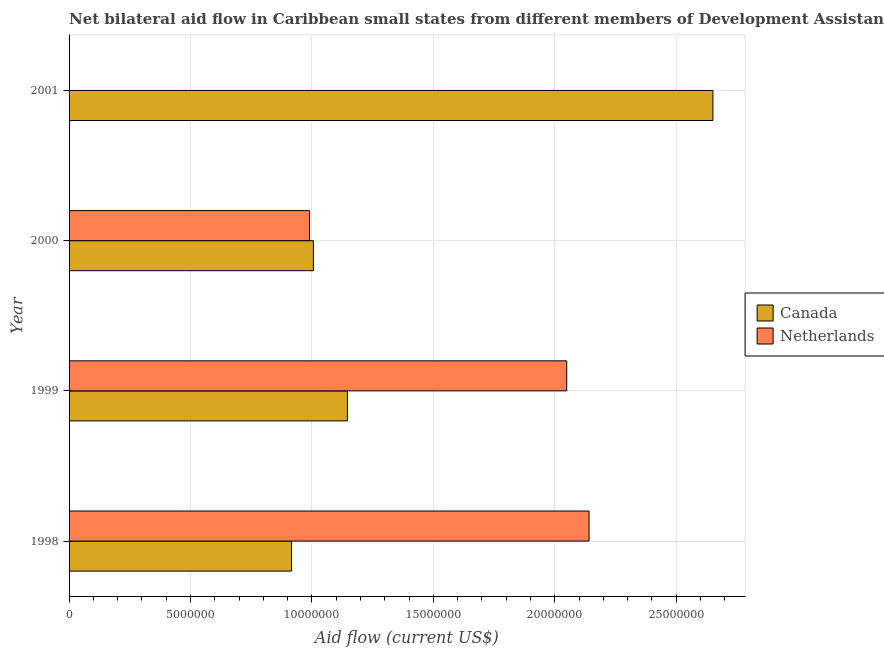How many different coloured bars are there?
Provide a short and direct response. 2. How many bars are there on the 3rd tick from the top?
Offer a very short reply. 2. How many bars are there on the 2nd tick from the bottom?
Ensure brevity in your answer.  2. What is the label of the 1st group of bars from the top?
Your answer should be compact. 2001. In how many cases, is the number of bars for a given year not equal to the number of legend labels?
Provide a short and direct response. 1. What is the amount of aid given by canada in 1998?
Make the answer very short. 9.16e+06. Across all years, what is the maximum amount of aid given by netherlands?
Your answer should be very brief. 2.14e+07. Across all years, what is the minimum amount of aid given by canada?
Provide a short and direct response. 9.16e+06. In which year was the amount of aid given by canada maximum?
Offer a terse response. 2001. What is the total amount of aid given by canada in the graph?
Give a very brief answer. 5.72e+07. What is the difference between the amount of aid given by canada in 1998 and that in 2001?
Give a very brief answer. -1.74e+07. What is the difference between the amount of aid given by canada in 1999 and the amount of aid given by netherlands in 1998?
Make the answer very short. -9.95e+06. What is the average amount of aid given by canada per year?
Provide a succinct answer. 1.43e+07. In the year 1998, what is the difference between the amount of aid given by canada and amount of aid given by netherlands?
Make the answer very short. -1.22e+07. What is the ratio of the amount of aid given by canada in 1999 to that in 2000?
Offer a very short reply. 1.14. Is the amount of aid given by canada in 1999 less than that in 2000?
Provide a succinct answer. No. Is the difference between the amount of aid given by netherlands in 1998 and 1999 greater than the difference between the amount of aid given by canada in 1998 and 1999?
Your answer should be compact. Yes. What is the difference between the highest and the second highest amount of aid given by netherlands?
Your answer should be compact. 9.20e+05. What is the difference between the highest and the lowest amount of aid given by canada?
Keep it short and to the point. 1.74e+07. In how many years, is the amount of aid given by canada greater than the average amount of aid given by canada taken over all years?
Make the answer very short. 1. How many years are there in the graph?
Your response must be concise. 4. Does the graph contain grids?
Your answer should be compact. Yes. Where does the legend appear in the graph?
Keep it short and to the point. Center right. How many legend labels are there?
Make the answer very short. 2. How are the legend labels stacked?
Offer a terse response. Vertical. What is the title of the graph?
Make the answer very short. Net bilateral aid flow in Caribbean small states from different members of Development Assistance Committee. What is the label or title of the Y-axis?
Your answer should be very brief. Year. What is the Aid flow (current US$) of Canada in 1998?
Your response must be concise. 9.16e+06. What is the Aid flow (current US$) in Netherlands in 1998?
Offer a very short reply. 2.14e+07. What is the Aid flow (current US$) of Canada in 1999?
Make the answer very short. 1.15e+07. What is the Aid flow (current US$) of Netherlands in 1999?
Your response must be concise. 2.05e+07. What is the Aid flow (current US$) of Canada in 2000?
Ensure brevity in your answer.  1.01e+07. What is the Aid flow (current US$) of Netherlands in 2000?
Make the answer very short. 9.90e+06. What is the Aid flow (current US$) in Canada in 2001?
Your answer should be compact. 2.65e+07. Across all years, what is the maximum Aid flow (current US$) in Canada?
Offer a terse response. 2.65e+07. Across all years, what is the maximum Aid flow (current US$) of Netherlands?
Give a very brief answer. 2.14e+07. Across all years, what is the minimum Aid flow (current US$) in Canada?
Ensure brevity in your answer.  9.16e+06. What is the total Aid flow (current US$) of Canada in the graph?
Offer a terse response. 5.72e+07. What is the total Aid flow (current US$) in Netherlands in the graph?
Give a very brief answer. 5.18e+07. What is the difference between the Aid flow (current US$) in Canada in 1998 and that in 1999?
Ensure brevity in your answer.  -2.30e+06. What is the difference between the Aid flow (current US$) in Netherlands in 1998 and that in 1999?
Give a very brief answer. 9.20e+05. What is the difference between the Aid flow (current US$) in Canada in 1998 and that in 2000?
Ensure brevity in your answer.  -9.00e+05. What is the difference between the Aid flow (current US$) of Netherlands in 1998 and that in 2000?
Your answer should be very brief. 1.15e+07. What is the difference between the Aid flow (current US$) in Canada in 1998 and that in 2001?
Your answer should be very brief. -1.74e+07. What is the difference between the Aid flow (current US$) of Canada in 1999 and that in 2000?
Offer a terse response. 1.40e+06. What is the difference between the Aid flow (current US$) of Netherlands in 1999 and that in 2000?
Provide a short and direct response. 1.06e+07. What is the difference between the Aid flow (current US$) in Canada in 1999 and that in 2001?
Provide a short and direct response. -1.50e+07. What is the difference between the Aid flow (current US$) of Canada in 2000 and that in 2001?
Your response must be concise. -1.64e+07. What is the difference between the Aid flow (current US$) of Canada in 1998 and the Aid flow (current US$) of Netherlands in 1999?
Keep it short and to the point. -1.13e+07. What is the difference between the Aid flow (current US$) in Canada in 1998 and the Aid flow (current US$) in Netherlands in 2000?
Offer a terse response. -7.40e+05. What is the difference between the Aid flow (current US$) in Canada in 1999 and the Aid flow (current US$) in Netherlands in 2000?
Make the answer very short. 1.56e+06. What is the average Aid flow (current US$) of Canada per year?
Offer a very short reply. 1.43e+07. What is the average Aid flow (current US$) in Netherlands per year?
Ensure brevity in your answer.  1.30e+07. In the year 1998, what is the difference between the Aid flow (current US$) in Canada and Aid flow (current US$) in Netherlands?
Your answer should be compact. -1.22e+07. In the year 1999, what is the difference between the Aid flow (current US$) in Canada and Aid flow (current US$) in Netherlands?
Keep it short and to the point. -9.03e+06. In the year 2000, what is the difference between the Aid flow (current US$) of Canada and Aid flow (current US$) of Netherlands?
Provide a succinct answer. 1.60e+05. What is the ratio of the Aid flow (current US$) in Canada in 1998 to that in 1999?
Your response must be concise. 0.8. What is the ratio of the Aid flow (current US$) of Netherlands in 1998 to that in 1999?
Offer a terse response. 1.04. What is the ratio of the Aid flow (current US$) in Canada in 1998 to that in 2000?
Give a very brief answer. 0.91. What is the ratio of the Aid flow (current US$) of Netherlands in 1998 to that in 2000?
Your answer should be compact. 2.16. What is the ratio of the Aid flow (current US$) in Canada in 1998 to that in 2001?
Keep it short and to the point. 0.35. What is the ratio of the Aid flow (current US$) of Canada in 1999 to that in 2000?
Ensure brevity in your answer.  1.14. What is the ratio of the Aid flow (current US$) of Netherlands in 1999 to that in 2000?
Give a very brief answer. 2.07. What is the ratio of the Aid flow (current US$) of Canada in 1999 to that in 2001?
Make the answer very short. 0.43. What is the ratio of the Aid flow (current US$) of Canada in 2000 to that in 2001?
Provide a short and direct response. 0.38. What is the difference between the highest and the second highest Aid flow (current US$) in Canada?
Provide a short and direct response. 1.50e+07. What is the difference between the highest and the second highest Aid flow (current US$) in Netherlands?
Your answer should be very brief. 9.20e+05. What is the difference between the highest and the lowest Aid flow (current US$) in Canada?
Your answer should be very brief. 1.74e+07. What is the difference between the highest and the lowest Aid flow (current US$) of Netherlands?
Make the answer very short. 2.14e+07. 